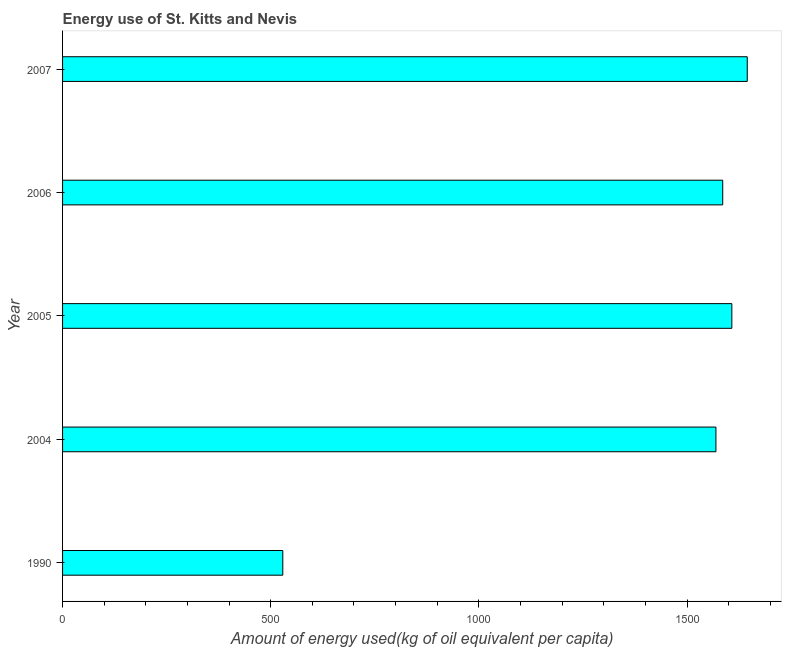Does the graph contain any zero values?
Provide a short and direct response. No. What is the title of the graph?
Offer a terse response. Energy use of St. Kitts and Nevis. What is the label or title of the X-axis?
Provide a short and direct response. Amount of energy used(kg of oil equivalent per capita). What is the amount of energy used in 2005?
Offer a very short reply. 1607.68. Across all years, what is the maximum amount of energy used?
Offer a very short reply. 1644.7. Across all years, what is the minimum amount of energy used?
Provide a short and direct response. 529. In which year was the amount of energy used minimum?
Make the answer very short. 1990. What is the sum of the amount of energy used?
Give a very brief answer. 6936.64. What is the difference between the amount of energy used in 2004 and 2005?
Your answer should be very brief. -38.22. What is the average amount of energy used per year?
Provide a succinct answer. 1387.33. What is the median amount of energy used?
Your answer should be compact. 1585.77. Do a majority of the years between 1990 and 2004 (inclusive) have amount of energy used greater than 800 kg?
Keep it short and to the point. No. What is the ratio of the amount of energy used in 1990 to that in 2004?
Offer a very short reply. 0.34. Is the amount of energy used in 1990 less than that in 2007?
Ensure brevity in your answer.  Yes. What is the difference between the highest and the second highest amount of energy used?
Make the answer very short. 37.02. Is the sum of the amount of energy used in 1990 and 2006 greater than the maximum amount of energy used across all years?
Offer a terse response. Yes. What is the difference between the highest and the lowest amount of energy used?
Your answer should be very brief. 1115.7. What is the difference between two consecutive major ticks on the X-axis?
Offer a very short reply. 500. What is the Amount of energy used(kg of oil equivalent per capita) of 1990?
Your answer should be compact. 529. What is the Amount of energy used(kg of oil equivalent per capita) of 2004?
Your answer should be compact. 1569.47. What is the Amount of energy used(kg of oil equivalent per capita) in 2005?
Your answer should be compact. 1607.68. What is the Amount of energy used(kg of oil equivalent per capita) of 2006?
Offer a terse response. 1585.77. What is the Amount of energy used(kg of oil equivalent per capita) of 2007?
Provide a short and direct response. 1644.7. What is the difference between the Amount of energy used(kg of oil equivalent per capita) in 1990 and 2004?
Provide a short and direct response. -1040.46. What is the difference between the Amount of energy used(kg of oil equivalent per capita) in 1990 and 2005?
Offer a terse response. -1078.68. What is the difference between the Amount of energy used(kg of oil equivalent per capita) in 1990 and 2006?
Provide a short and direct response. -1056.77. What is the difference between the Amount of energy used(kg of oil equivalent per capita) in 1990 and 2007?
Your answer should be very brief. -1115.7. What is the difference between the Amount of energy used(kg of oil equivalent per capita) in 2004 and 2005?
Your response must be concise. -38.21. What is the difference between the Amount of energy used(kg of oil equivalent per capita) in 2004 and 2006?
Offer a very short reply. -16.3. What is the difference between the Amount of energy used(kg of oil equivalent per capita) in 2004 and 2007?
Offer a terse response. -75.23. What is the difference between the Amount of energy used(kg of oil equivalent per capita) in 2005 and 2006?
Your answer should be compact. 21.91. What is the difference between the Amount of energy used(kg of oil equivalent per capita) in 2005 and 2007?
Provide a short and direct response. -37.02. What is the difference between the Amount of energy used(kg of oil equivalent per capita) in 2006 and 2007?
Provide a succinct answer. -58.93. What is the ratio of the Amount of energy used(kg of oil equivalent per capita) in 1990 to that in 2004?
Your answer should be compact. 0.34. What is the ratio of the Amount of energy used(kg of oil equivalent per capita) in 1990 to that in 2005?
Your answer should be very brief. 0.33. What is the ratio of the Amount of energy used(kg of oil equivalent per capita) in 1990 to that in 2006?
Offer a very short reply. 0.33. What is the ratio of the Amount of energy used(kg of oil equivalent per capita) in 1990 to that in 2007?
Your answer should be compact. 0.32. What is the ratio of the Amount of energy used(kg of oil equivalent per capita) in 2004 to that in 2005?
Offer a terse response. 0.98. What is the ratio of the Amount of energy used(kg of oil equivalent per capita) in 2004 to that in 2006?
Your response must be concise. 0.99. What is the ratio of the Amount of energy used(kg of oil equivalent per capita) in 2004 to that in 2007?
Provide a short and direct response. 0.95. What is the ratio of the Amount of energy used(kg of oil equivalent per capita) in 2005 to that in 2006?
Offer a terse response. 1.01. 